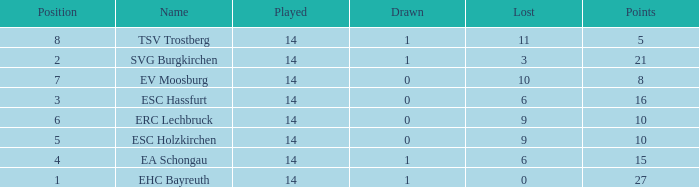What's the lost when there were more than 16 points and had a drawn less than 1? None. 